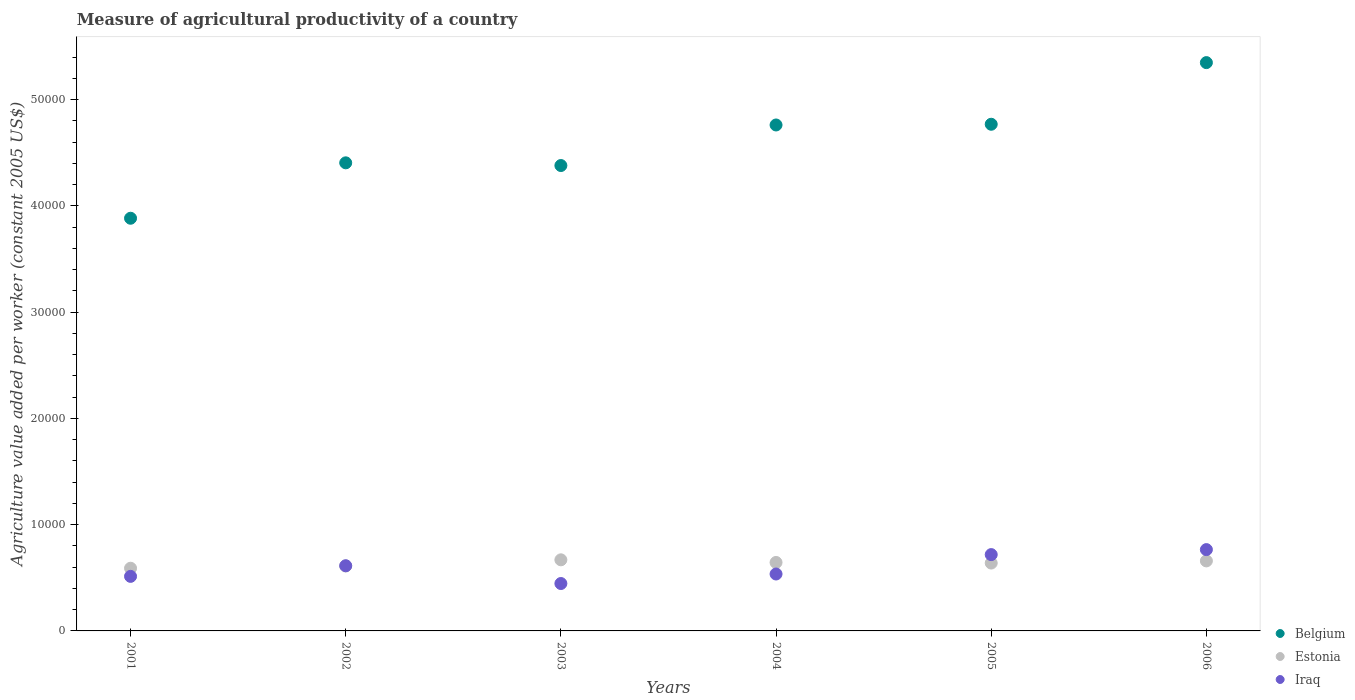What is the measure of agricultural productivity in Iraq in 2006?
Offer a very short reply. 7651.98. Across all years, what is the maximum measure of agricultural productivity in Iraq?
Your response must be concise. 7651.98. Across all years, what is the minimum measure of agricultural productivity in Iraq?
Keep it short and to the point. 4460.33. In which year was the measure of agricultural productivity in Iraq maximum?
Offer a terse response. 2006. In which year was the measure of agricultural productivity in Iraq minimum?
Offer a terse response. 2003. What is the total measure of agricultural productivity in Belgium in the graph?
Your answer should be compact. 2.75e+05. What is the difference between the measure of agricultural productivity in Estonia in 2004 and that in 2005?
Give a very brief answer. 57.06. What is the difference between the measure of agricultural productivity in Belgium in 2002 and the measure of agricultural productivity in Iraq in 2005?
Provide a succinct answer. 3.69e+04. What is the average measure of agricultural productivity in Iraq per year?
Give a very brief answer. 5986.31. In the year 2004, what is the difference between the measure of agricultural productivity in Belgium and measure of agricultural productivity in Estonia?
Your response must be concise. 4.12e+04. What is the ratio of the measure of agricultural productivity in Iraq in 2003 to that in 2006?
Provide a short and direct response. 0.58. Is the difference between the measure of agricultural productivity in Belgium in 2005 and 2006 greater than the difference between the measure of agricultural productivity in Estonia in 2005 and 2006?
Make the answer very short. No. What is the difference between the highest and the second highest measure of agricultural productivity in Belgium?
Provide a succinct answer. 5800.89. What is the difference between the highest and the lowest measure of agricultural productivity in Estonia?
Offer a terse response. 790.34. Is it the case that in every year, the sum of the measure of agricultural productivity in Estonia and measure of agricultural productivity in Iraq  is greater than the measure of agricultural productivity in Belgium?
Keep it short and to the point. No. Is the measure of agricultural productivity in Belgium strictly less than the measure of agricultural productivity in Iraq over the years?
Your answer should be compact. No. How many dotlines are there?
Your answer should be compact. 3. How many years are there in the graph?
Provide a short and direct response. 6. What is the difference between two consecutive major ticks on the Y-axis?
Provide a short and direct response. 10000. Does the graph contain any zero values?
Offer a very short reply. No. Does the graph contain grids?
Your response must be concise. No. Where does the legend appear in the graph?
Offer a terse response. Bottom right. How are the legend labels stacked?
Keep it short and to the point. Vertical. What is the title of the graph?
Ensure brevity in your answer.  Measure of agricultural productivity of a country. What is the label or title of the Y-axis?
Keep it short and to the point. Agriculture value added per worker (constant 2005 US$). What is the Agriculture value added per worker (constant 2005 US$) of Belgium in 2001?
Offer a very short reply. 3.88e+04. What is the Agriculture value added per worker (constant 2005 US$) in Estonia in 2001?
Offer a very short reply. 5900.31. What is the Agriculture value added per worker (constant 2005 US$) of Iraq in 2001?
Offer a terse response. 5133.38. What is the Agriculture value added per worker (constant 2005 US$) in Belgium in 2002?
Provide a succinct answer. 4.40e+04. What is the Agriculture value added per worker (constant 2005 US$) of Estonia in 2002?
Your response must be concise. 6107.91. What is the Agriculture value added per worker (constant 2005 US$) of Iraq in 2002?
Offer a terse response. 6133.84. What is the Agriculture value added per worker (constant 2005 US$) of Belgium in 2003?
Give a very brief answer. 4.38e+04. What is the Agriculture value added per worker (constant 2005 US$) of Estonia in 2003?
Provide a short and direct response. 6690.64. What is the Agriculture value added per worker (constant 2005 US$) of Iraq in 2003?
Provide a succinct answer. 4460.33. What is the Agriculture value added per worker (constant 2005 US$) in Belgium in 2004?
Ensure brevity in your answer.  4.76e+04. What is the Agriculture value added per worker (constant 2005 US$) of Estonia in 2004?
Your answer should be very brief. 6443.08. What is the Agriculture value added per worker (constant 2005 US$) of Iraq in 2004?
Give a very brief answer. 5356.05. What is the Agriculture value added per worker (constant 2005 US$) of Belgium in 2005?
Offer a very short reply. 4.77e+04. What is the Agriculture value added per worker (constant 2005 US$) of Estonia in 2005?
Provide a succinct answer. 6386.02. What is the Agriculture value added per worker (constant 2005 US$) of Iraq in 2005?
Your answer should be compact. 7182.31. What is the Agriculture value added per worker (constant 2005 US$) in Belgium in 2006?
Your answer should be compact. 5.35e+04. What is the Agriculture value added per worker (constant 2005 US$) of Estonia in 2006?
Provide a succinct answer. 6588.66. What is the Agriculture value added per worker (constant 2005 US$) of Iraq in 2006?
Provide a short and direct response. 7651.98. Across all years, what is the maximum Agriculture value added per worker (constant 2005 US$) of Belgium?
Ensure brevity in your answer.  5.35e+04. Across all years, what is the maximum Agriculture value added per worker (constant 2005 US$) of Estonia?
Ensure brevity in your answer.  6690.64. Across all years, what is the maximum Agriculture value added per worker (constant 2005 US$) of Iraq?
Give a very brief answer. 7651.98. Across all years, what is the minimum Agriculture value added per worker (constant 2005 US$) of Belgium?
Make the answer very short. 3.88e+04. Across all years, what is the minimum Agriculture value added per worker (constant 2005 US$) in Estonia?
Offer a very short reply. 5900.31. Across all years, what is the minimum Agriculture value added per worker (constant 2005 US$) in Iraq?
Your response must be concise. 4460.33. What is the total Agriculture value added per worker (constant 2005 US$) of Belgium in the graph?
Ensure brevity in your answer.  2.75e+05. What is the total Agriculture value added per worker (constant 2005 US$) of Estonia in the graph?
Provide a succinct answer. 3.81e+04. What is the total Agriculture value added per worker (constant 2005 US$) of Iraq in the graph?
Your answer should be compact. 3.59e+04. What is the difference between the Agriculture value added per worker (constant 2005 US$) in Belgium in 2001 and that in 2002?
Keep it short and to the point. -5214.41. What is the difference between the Agriculture value added per worker (constant 2005 US$) in Estonia in 2001 and that in 2002?
Your answer should be very brief. -207.6. What is the difference between the Agriculture value added per worker (constant 2005 US$) of Iraq in 2001 and that in 2002?
Give a very brief answer. -1000.47. What is the difference between the Agriculture value added per worker (constant 2005 US$) in Belgium in 2001 and that in 2003?
Provide a short and direct response. -4960.1. What is the difference between the Agriculture value added per worker (constant 2005 US$) in Estonia in 2001 and that in 2003?
Your answer should be compact. -790.34. What is the difference between the Agriculture value added per worker (constant 2005 US$) of Iraq in 2001 and that in 2003?
Keep it short and to the point. 673.05. What is the difference between the Agriculture value added per worker (constant 2005 US$) of Belgium in 2001 and that in 2004?
Your answer should be very brief. -8776.7. What is the difference between the Agriculture value added per worker (constant 2005 US$) in Estonia in 2001 and that in 2004?
Keep it short and to the point. -542.77. What is the difference between the Agriculture value added per worker (constant 2005 US$) in Iraq in 2001 and that in 2004?
Your answer should be very brief. -222.67. What is the difference between the Agriculture value added per worker (constant 2005 US$) in Belgium in 2001 and that in 2005?
Give a very brief answer. -8843.6. What is the difference between the Agriculture value added per worker (constant 2005 US$) of Estonia in 2001 and that in 2005?
Provide a short and direct response. -485.71. What is the difference between the Agriculture value added per worker (constant 2005 US$) in Iraq in 2001 and that in 2005?
Your response must be concise. -2048.93. What is the difference between the Agriculture value added per worker (constant 2005 US$) of Belgium in 2001 and that in 2006?
Offer a terse response. -1.46e+04. What is the difference between the Agriculture value added per worker (constant 2005 US$) in Estonia in 2001 and that in 2006?
Your answer should be compact. -688.35. What is the difference between the Agriculture value added per worker (constant 2005 US$) of Iraq in 2001 and that in 2006?
Your answer should be very brief. -2518.6. What is the difference between the Agriculture value added per worker (constant 2005 US$) in Belgium in 2002 and that in 2003?
Make the answer very short. 254.31. What is the difference between the Agriculture value added per worker (constant 2005 US$) of Estonia in 2002 and that in 2003?
Give a very brief answer. -582.74. What is the difference between the Agriculture value added per worker (constant 2005 US$) of Iraq in 2002 and that in 2003?
Provide a short and direct response. 1673.51. What is the difference between the Agriculture value added per worker (constant 2005 US$) in Belgium in 2002 and that in 2004?
Give a very brief answer. -3562.28. What is the difference between the Agriculture value added per worker (constant 2005 US$) in Estonia in 2002 and that in 2004?
Ensure brevity in your answer.  -335.17. What is the difference between the Agriculture value added per worker (constant 2005 US$) in Iraq in 2002 and that in 2004?
Your answer should be very brief. 777.79. What is the difference between the Agriculture value added per worker (constant 2005 US$) of Belgium in 2002 and that in 2005?
Make the answer very short. -3629.19. What is the difference between the Agriculture value added per worker (constant 2005 US$) of Estonia in 2002 and that in 2005?
Your answer should be compact. -278.11. What is the difference between the Agriculture value added per worker (constant 2005 US$) of Iraq in 2002 and that in 2005?
Provide a short and direct response. -1048.46. What is the difference between the Agriculture value added per worker (constant 2005 US$) of Belgium in 2002 and that in 2006?
Make the answer very short. -9430.07. What is the difference between the Agriculture value added per worker (constant 2005 US$) of Estonia in 2002 and that in 2006?
Your response must be concise. -480.75. What is the difference between the Agriculture value added per worker (constant 2005 US$) of Iraq in 2002 and that in 2006?
Keep it short and to the point. -1518.14. What is the difference between the Agriculture value added per worker (constant 2005 US$) of Belgium in 2003 and that in 2004?
Give a very brief answer. -3816.6. What is the difference between the Agriculture value added per worker (constant 2005 US$) in Estonia in 2003 and that in 2004?
Offer a very short reply. 247.56. What is the difference between the Agriculture value added per worker (constant 2005 US$) in Iraq in 2003 and that in 2004?
Your answer should be very brief. -895.72. What is the difference between the Agriculture value added per worker (constant 2005 US$) in Belgium in 2003 and that in 2005?
Provide a short and direct response. -3883.5. What is the difference between the Agriculture value added per worker (constant 2005 US$) in Estonia in 2003 and that in 2005?
Keep it short and to the point. 304.62. What is the difference between the Agriculture value added per worker (constant 2005 US$) of Iraq in 2003 and that in 2005?
Ensure brevity in your answer.  -2721.98. What is the difference between the Agriculture value added per worker (constant 2005 US$) in Belgium in 2003 and that in 2006?
Offer a very short reply. -9684.39. What is the difference between the Agriculture value added per worker (constant 2005 US$) in Estonia in 2003 and that in 2006?
Keep it short and to the point. 101.99. What is the difference between the Agriculture value added per worker (constant 2005 US$) in Iraq in 2003 and that in 2006?
Keep it short and to the point. -3191.65. What is the difference between the Agriculture value added per worker (constant 2005 US$) of Belgium in 2004 and that in 2005?
Offer a very short reply. -66.9. What is the difference between the Agriculture value added per worker (constant 2005 US$) of Estonia in 2004 and that in 2005?
Make the answer very short. 57.06. What is the difference between the Agriculture value added per worker (constant 2005 US$) of Iraq in 2004 and that in 2005?
Your answer should be very brief. -1826.26. What is the difference between the Agriculture value added per worker (constant 2005 US$) of Belgium in 2004 and that in 2006?
Your response must be concise. -5867.79. What is the difference between the Agriculture value added per worker (constant 2005 US$) in Estonia in 2004 and that in 2006?
Provide a short and direct response. -145.58. What is the difference between the Agriculture value added per worker (constant 2005 US$) of Iraq in 2004 and that in 2006?
Offer a terse response. -2295.93. What is the difference between the Agriculture value added per worker (constant 2005 US$) in Belgium in 2005 and that in 2006?
Provide a succinct answer. -5800.89. What is the difference between the Agriculture value added per worker (constant 2005 US$) of Estonia in 2005 and that in 2006?
Offer a very short reply. -202.64. What is the difference between the Agriculture value added per worker (constant 2005 US$) in Iraq in 2005 and that in 2006?
Your answer should be compact. -469.67. What is the difference between the Agriculture value added per worker (constant 2005 US$) in Belgium in 2001 and the Agriculture value added per worker (constant 2005 US$) in Estonia in 2002?
Your response must be concise. 3.27e+04. What is the difference between the Agriculture value added per worker (constant 2005 US$) of Belgium in 2001 and the Agriculture value added per worker (constant 2005 US$) of Iraq in 2002?
Make the answer very short. 3.27e+04. What is the difference between the Agriculture value added per worker (constant 2005 US$) in Estonia in 2001 and the Agriculture value added per worker (constant 2005 US$) in Iraq in 2002?
Give a very brief answer. -233.53. What is the difference between the Agriculture value added per worker (constant 2005 US$) of Belgium in 2001 and the Agriculture value added per worker (constant 2005 US$) of Estonia in 2003?
Provide a short and direct response. 3.21e+04. What is the difference between the Agriculture value added per worker (constant 2005 US$) in Belgium in 2001 and the Agriculture value added per worker (constant 2005 US$) in Iraq in 2003?
Provide a short and direct response. 3.44e+04. What is the difference between the Agriculture value added per worker (constant 2005 US$) of Estonia in 2001 and the Agriculture value added per worker (constant 2005 US$) of Iraq in 2003?
Provide a succinct answer. 1439.98. What is the difference between the Agriculture value added per worker (constant 2005 US$) in Belgium in 2001 and the Agriculture value added per worker (constant 2005 US$) in Estonia in 2004?
Ensure brevity in your answer.  3.24e+04. What is the difference between the Agriculture value added per worker (constant 2005 US$) in Belgium in 2001 and the Agriculture value added per worker (constant 2005 US$) in Iraq in 2004?
Make the answer very short. 3.35e+04. What is the difference between the Agriculture value added per worker (constant 2005 US$) of Estonia in 2001 and the Agriculture value added per worker (constant 2005 US$) of Iraq in 2004?
Your answer should be very brief. 544.26. What is the difference between the Agriculture value added per worker (constant 2005 US$) of Belgium in 2001 and the Agriculture value added per worker (constant 2005 US$) of Estonia in 2005?
Your response must be concise. 3.24e+04. What is the difference between the Agriculture value added per worker (constant 2005 US$) of Belgium in 2001 and the Agriculture value added per worker (constant 2005 US$) of Iraq in 2005?
Ensure brevity in your answer.  3.17e+04. What is the difference between the Agriculture value added per worker (constant 2005 US$) of Estonia in 2001 and the Agriculture value added per worker (constant 2005 US$) of Iraq in 2005?
Keep it short and to the point. -1282. What is the difference between the Agriculture value added per worker (constant 2005 US$) of Belgium in 2001 and the Agriculture value added per worker (constant 2005 US$) of Estonia in 2006?
Ensure brevity in your answer.  3.22e+04. What is the difference between the Agriculture value added per worker (constant 2005 US$) of Belgium in 2001 and the Agriculture value added per worker (constant 2005 US$) of Iraq in 2006?
Your answer should be compact. 3.12e+04. What is the difference between the Agriculture value added per worker (constant 2005 US$) in Estonia in 2001 and the Agriculture value added per worker (constant 2005 US$) in Iraq in 2006?
Give a very brief answer. -1751.67. What is the difference between the Agriculture value added per worker (constant 2005 US$) of Belgium in 2002 and the Agriculture value added per worker (constant 2005 US$) of Estonia in 2003?
Make the answer very short. 3.74e+04. What is the difference between the Agriculture value added per worker (constant 2005 US$) in Belgium in 2002 and the Agriculture value added per worker (constant 2005 US$) in Iraq in 2003?
Make the answer very short. 3.96e+04. What is the difference between the Agriculture value added per worker (constant 2005 US$) in Estonia in 2002 and the Agriculture value added per worker (constant 2005 US$) in Iraq in 2003?
Give a very brief answer. 1647.58. What is the difference between the Agriculture value added per worker (constant 2005 US$) of Belgium in 2002 and the Agriculture value added per worker (constant 2005 US$) of Estonia in 2004?
Make the answer very short. 3.76e+04. What is the difference between the Agriculture value added per worker (constant 2005 US$) of Belgium in 2002 and the Agriculture value added per worker (constant 2005 US$) of Iraq in 2004?
Offer a very short reply. 3.87e+04. What is the difference between the Agriculture value added per worker (constant 2005 US$) in Estonia in 2002 and the Agriculture value added per worker (constant 2005 US$) in Iraq in 2004?
Offer a terse response. 751.86. What is the difference between the Agriculture value added per worker (constant 2005 US$) in Belgium in 2002 and the Agriculture value added per worker (constant 2005 US$) in Estonia in 2005?
Your response must be concise. 3.77e+04. What is the difference between the Agriculture value added per worker (constant 2005 US$) in Belgium in 2002 and the Agriculture value added per worker (constant 2005 US$) in Iraq in 2005?
Keep it short and to the point. 3.69e+04. What is the difference between the Agriculture value added per worker (constant 2005 US$) of Estonia in 2002 and the Agriculture value added per worker (constant 2005 US$) of Iraq in 2005?
Ensure brevity in your answer.  -1074.4. What is the difference between the Agriculture value added per worker (constant 2005 US$) of Belgium in 2002 and the Agriculture value added per worker (constant 2005 US$) of Estonia in 2006?
Provide a short and direct response. 3.75e+04. What is the difference between the Agriculture value added per worker (constant 2005 US$) in Belgium in 2002 and the Agriculture value added per worker (constant 2005 US$) in Iraq in 2006?
Ensure brevity in your answer.  3.64e+04. What is the difference between the Agriculture value added per worker (constant 2005 US$) of Estonia in 2002 and the Agriculture value added per worker (constant 2005 US$) of Iraq in 2006?
Offer a terse response. -1544.07. What is the difference between the Agriculture value added per worker (constant 2005 US$) in Belgium in 2003 and the Agriculture value added per worker (constant 2005 US$) in Estonia in 2004?
Your answer should be compact. 3.74e+04. What is the difference between the Agriculture value added per worker (constant 2005 US$) in Belgium in 2003 and the Agriculture value added per worker (constant 2005 US$) in Iraq in 2004?
Give a very brief answer. 3.84e+04. What is the difference between the Agriculture value added per worker (constant 2005 US$) in Estonia in 2003 and the Agriculture value added per worker (constant 2005 US$) in Iraq in 2004?
Keep it short and to the point. 1334.59. What is the difference between the Agriculture value added per worker (constant 2005 US$) of Belgium in 2003 and the Agriculture value added per worker (constant 2005 US$) of Estonia in 2005?
Offer a very short reply. 3.74e+04. What is the difference between the Agriculture value added per worker (constant 2005 US$) of Belgium in 2003 and the Agriculture value added per worker (constant 2005 US$) of Iraq in 2005?
Offer a very short reply. 3.66e+04. What is the difference between the Agriculture value added per worker (constant 2005 US$) in Estonia in 2003 and the Agriculture value added per worker (constant 2005 US$) in Iraq in 2005?
Offer a terse response. -491.66. What is the difference between the Agriculture value added per worker (constant 2005 US$) in Belgium in 2003 and the Agriculture value added per worker (constant 2005 US$) in Estonia in 2006?
Keep it short and to the point. 3.72e+04. What is the difference between the Agriculture value added per worker (constant 2005 US$) in Belgium in 2003 and the Agriculture value added per worker (constant 2005 US$) in Iraq in 2006?
Ensure brevity in your answer.  3.61e+04. What is the difference between the Agriculture value added per worker (constant 2005 US$) of Estonia in 2003 and the Agriculture value added per worker (constant 2005 US$) of Iraq in 2006?
Make the answer very short. -961.33. What is the difference between the Agriculture value added per worker (constant 2005 US$) in Belgium in 2004 and the Agriculture value added per worker (constant 2005 US$) in Estonia in 2005?
Ensure brevity in your answer.  4.12e+04. What is the difference between the Agriculture value added per worker (constant 2005 US$) in Belgium in 2004 and the Agriculture value added per worker (constant 2005 US$) in Iraq in 2005?
Your answer should be very brief. 4.04e+04. What is the difference between the Agriculture value added per worker (constant 2005 US$) of Estonia in 2004 and the Agriculture value added per worker (constant 2005 US$) of Iraq in 2005?
Provide a succinct answer. -739.23. What is the difference between the Agriculture value added per worker (constant 2005 US$) in Belgium in 2004 and the Agriculture value added per worker (constant 2005 US$) in Estonia in 2006?
Offer a terse response. 4.10e+04. What is the difference between the Agriculture value added per worker (constant 2005 US$) in Belgium in 2004 and the Agriculture value added per worker (constant 2005 US$) in Iraq in 2006?
Your answer should be very brief. 4.00e+04. What is the difference between the Agriculture value added per worker (constant 2005 US$) of Estonia in 2004 and the Agriculture value added per worker (constant 2005 US$) of Iraq in 2006?
Provide a succinct answer. -1208.9. What is the difference between the Agriculture value added per worker (constant 2005 US$) in Belgium in 2005 and the Agriculture value added per worker (constant 2005 US$) in Estonia in 2006?
Provide a succinct answer. 4.11e+04. What is the difference between the Agriculture value added per worker (constant 2005 US$) in Belgium in 2005 and the Agriculture value added per worker (constant 2005 US$) in Iraq in 2006?
Keep it short and to the point. 4.00e+04. What is the difference between the Agriculture value added per worker (constant 2005 US$) of Estonia in 2005 and the Agriculture value added per worker (constant 2005 US$) of Iraq in 2006?
Offer a terse response. -1265.96. What is the average Agriculture value added per worker (constant 2005 US$) of Belgium per year?
Your answer should be very brief. 4.59e+04. What is the average Agriculture value added per worker (constant 2005 US$) in Estonia per year?
Your answer should be compact. 6352.77. What is the average Agriculture value added per worker (constant 2005 US$) of Iraq per year?
Offer a terse response. 5986.31. In the year 2001, what is the difference between the Agriculture value added per worker (constant 2005 US$) in Belgium and Agriculture value added per worker (constant 2005 US$) in Estonia?
Give a very brief answer. 3.29e+04. In the year 2001, what is the difference between the Agriculture value added per worker (constant 2005 US$) in Belgium and Agriculture value added per worker (constant 2005 US$) in Iraq?
Make the answer very short. 3.37e+04. In the year 2001, what is the difference between the Agriculture value added per worker (constant 2005 US$) of Estonia and Agriculture value added per worker (constant 2005 US$) of Iraq?
Offer a terse response. 766.93. In the year 2002, what is the difference between the Agriculture value added per worker (constant 2005 US$) of Belgium and Agriculture value added per worker (constant 2005 US$) of Estonia?
Ensure brevity in your answer.  3.79e+04. In the year 2002, what is the difference between the Agriculture value added per worker (constant 2005 US$) of Belgium and Agriculture value added per worker (constant 2005 US$) of Iraq?
Keep it short and to the point. 3.79e+04. In the year 2002, what is the difference between the Agriculture value added per worker (constant 2005 US$) in Estonia and Agriculture value added per worker (constant 2005 US$) in Iraq?
Offer a terse response. -25.93. In the year 2003, what is the difference between the Agriculture value added per worker (constant 2005 US$) of Belgium and Agriculture value added per worker (constant 2005 US$) of Estonia?
Give a very brief answer. 3.71e+04. In the year 2003, what is the difference between the Agriculture value added per worker (constant 2005 US$) of Belgium and Agriculture value added per worker (constant 2005 US$) of Iraq?
Provide a short and direct response. 3.93e+04. In the year 2003, what is the difference between the Agriculture value added per worker (constant 2005 US$) of Estonia and Agriculture value added per worker (constant 2005 US$) of Iraq?
Your answer should be very brief. 2230.32. In the year 2004, what is the difference between the Agriculture value added per worker (constant 2005 US$) in Belgium and Agriculture value added per worker (constant 2005 US$) in Estonia?
Give a very brief answer. 4.12e+04. In the year 2004, what is the difference between the Agriculture value added per worker (constant 2005 US$) in Belgium and Agriculture value added per worker (constant 2005 US$) in Iraq?
Keep it short and to the point. 4.23e+04. In the year 2004, what is the difference between the Agriculture value added per worker (constant 2005 US$) in Estonia and Agriculture value added per worker (constant 2005 US$) in Iraq?
Make the answer very short. 1087.03. In the year 2005, what is the difference between the Agriculture value added per worker (constant 2005 US$) of Belgium and Agriculture value added per worker (constant 2005 US$) of Estonia?
Keep it short and to the point. 4.13e+04. In the year 2005, what is the difference between the Agriculture value added per worker (constant 2005 US$) in Belgium and Agriculture value added per worker (constant 2005 US$) in Iraq?
Provide a short and direct response. 4.05e+04. In the year 2005, what is the difference between the Agriculture value added per worker (constant 2005 US$) of Estonia and Agriculture value added per worker (constant 2005 US$) of Iraq?
Make the answer very short. -796.28. In the year 2006, what is the difference between the Agriculture value added per worker (constant 2005 US$) in Belgium and Agriculture value added per worker (constant 2005 US$) in Estonia?
Provide a short and direct response. 4.69e+04. In the year 2006, what is the difference between the Agriculture value added per worker (constant 2005 US$) in Belgium and Agriculture value added per worker (constant 2005 US$) in Iraq?
Keep it short and to the point. 4.58e+04. In the year 2006, what is the difference between the Agriculture value added per worker (constant 2005 US$) of Estonia and Agriculture value added per worker (constant 2005 US$) of Iraq?
Your answer should be compact. -1063.32. What is the ratio of the Agriculture value added per worker (constant 2005 US$) in Belgium in 2001 to that in 2002?
Your answer should be compact. 0.88. What is the ratio of the Agriculture value added per worker (constant 2005 US$) in Iraq in 2001 to that in 2002?
Your response must be concise. 0.84. What is the ratio of the Agriculture value added per worker (constant 2005 US$) of Belgium in 2001 to that in 2003?
Your answer should be compact. 0.89. What is the ratio of the Agriculture value added per worker (constant 2005 US$) in Estonia in 2001 to that in 2003?
Make the answer very short. 0.88. What is the ratio of the Agriculture value added per worker (constant 2005 US$) of Iraq in 2001 to that in 2003?
Offer a very short reply. 1.15. What is the ratio of the Agriculture value added per worker (constant 2005 US$) in Belgium in 2001 to that in 2004?
Your answer should be compact. 0.82. What is the ratio of the Agriculture value added per worker (constant 2005 US$) in Estonia in 2001 to that in 2004?
Make the answer very short. 0.92. What is the ratio of the Agriculture value added per worker (constant 2005 US$) in Iraq in 2001 to that in 2004?
Offer a very short reply. 0.96. What is the ratio of the Agriculture value added per worker (constant 2005 US$) of Belgium in 2001 to that in 2005?
Ensure brevity in your answer.  0.81. What is the ratio of the Agriculture value added per worker (constant 2005 US$) in Estonia in 2001 to that in 2005?
Your answer should be compact. 0.92. What is the ratio of the Agriculture value added per worker (constant 2005 US$) in Iraq in 2001 to that in 2005?
Offer a terse response. 0.71. What is the ratio of the Agriculture value added per worker (constant 2005 US$) of Belgium in 2001 to that in 2006?
Provide a succinct answer. 0.73. What is the ratio of the Agriculture value added per worker (constant 2005 US$) in Estonia in 2001 to that in 2006?
Keep it short and to the point. 0.9. What is the ratio of the Agriculture value added per worker (constant 2005 US$) of Iraq in 2001 to that in 2006?
Offer a very short reply. 0.67. What is the ratio of the Agriculture value added per worker (constant 2005 US$) of Estonia in 2002 to that in 2003?
Ensure brevity in your answer.  0.91. What is the ratio of the Agriculture value added per worker (constant 2005 US$) in Iraq in 2002 to that in 2003?
Your response must be concise. 1.38. What is the ratio of the Agriculture value added per worker (constant 2005 US$) in Belgium in 2002 to that in 2004?
Your answer should be compact. 0.93. What is the ratio of the Agriculture value added per worker (constant 2005 US$) in Estonia in 2002 to that in 2004?
Your answer should be compact. 0.95. What is the ratio of the Agriculture value added per worker (constant 2005 US$) in Iraq in 2002 to that in 2004?
Keep it short and to the point. 1.15. What is the ratio of the Agriculture value added per worker (constant 2005 US$) in Belgium in 2002 to that in 2005?
Offer a terse response. 0.92. What is the ratio of the Agriculture value added per worker (constant 2005 US$) of Estonia in 2002 to that in 2005?
Make the answer very short. 0.96. What is the ratio of the Agriculture value added per worker (constant 2005 US$) in Iraq in 2002 to that in 2005?
Your answer should be very brief. 0.85. What is the ratio of the Agriculture value added per worker (constant 2005 US$) in Belgium in 2002 to that in 2006?
Provide a succinct answer. 0.82. What is the ratio of the Agriculture value added per worker (constant 2005 US$) of Estonia in 2002 to that in 2006?
Your answer should be very brief. 0.93. What is the ratio of the Agriculture value added per worker (constant 2005 US$) in Iraq in 2002 to that in 2006?
Make the answer very short. 0.8. What is the ratio of the Agriculture value added per worker (constant 2005 US$) of Belgium in 2003 to that in 2004?
Offer a terse response. 0.92. What is the ratio of the Agriculture value added per worker (constant 2005 US$) in Estonia in 2003 to that in 2004?
Keep it short and to the point. 1.04. What is the ratio of the Agriculture value added per worker (constant 2005 US$) of Iraq in 2003 to that in 2004?
Ensure brevity in your answer.  0.83. What is the ratio of the Agriculture value added per worker (constant 2005 US$) of Belgium in 2003 to that in 2005?
Provide a short and direct response. 0.92. What is the ratio of the Agriculture value added per worker (constant 2005 US$) in Estonia in 2003 to that in 2005?
Your answer should be very brief. 1.05. What is the ratio of the Agriculture value added per worker (constant 2005 US$) of Iraq in 2003 to that in 2005?
Your response must be concise. 0.62. What is the ratio of the Agriculture value added per worker (constant 2005 US$) of Belgium in 2003 to that in 2006?
Make the answer very short. 0.82. What is the ratio of the Agriculture value added per worker (constant 2005 US$) of Estonia in 2003 to that in 2006?
Your answer should be compact. 1.02. What is the ratio of the Agriculture value added per worker (constant 2005 US$) of Iraq in 2003 to that in 2006?
Ensure brevity in your answer.  0.58. What is the ratio of the Agriculture value added per worker (constant 2005 US$) of Belgium in 2004 to that in 2005?
Provide a short and direct response. 1. What is the ratio of the Agriculture value added per worker (constant 2005 US$) in Estonia in 2004 to that in 2005?
Your answer should be compact. 1.01. What is the ratio of the Agriculture value added per worker (constant 2005 US$) in Iraq in 2004 to that in 2005?
Provide a succinct answer. 0.75. What is the ratio of the Agriculture value added per worker (constant 2005 US$) of Belgium in 2004 to that in 2006?
Ensure brevity in your answer.  0.89. What is the ratio of the Agriculture value added per worker (constant 2005 US$) in Estonia in 2004 to that in 2006?
Keep it short and to the point. 0.98. What is the ratio of the Agriculture value added per worker (constant 2005 US$) in Belgium in 2005 to that in 2006?
Provide a succinct answer. 0.89. What is the ratio of the Agriculture value added per worker (constant 2005 US$) of Estonia in 2005 to that in 2006?
Provide a succinct answer. 0.97. What is the ratio of the Agriculture value added per worker (constant 2005 US$) in Iraq in 2005 to that in 2006?
Provide a succinct answer. 0.94. What is the difference between the highest and the second highest Agriculture value added per worker (constant 2005 US$) in Belgium?
Ensure brevity in your answer.  5800.89. What is the difference between the highest and the second highest Agriculture value added per worker (constant 2005 US$) of Estonia?
Make the answer very short. 101.99. What is the difference between the highest and the second highest Agriculture value added per worker (constant 2005 US$) of Iraq?
Provide a succinct answer. 469.67. What is the difference between the highest and the lowest Agriculture value added per worker (constant 2005 US$) of Belgium?
Ensure brevity in your answer.  1.46e+04. What is the difference between the highest and the lowest Agriculture value added per worker (constant 2005 US$) of Estonia?
Offer a very short reply. 790.34. What is the difference between the highest and the lowest Agriculture value added per worker (constant 2005 US$) of Iraq?
Your answer should be compact. 3191.65. 